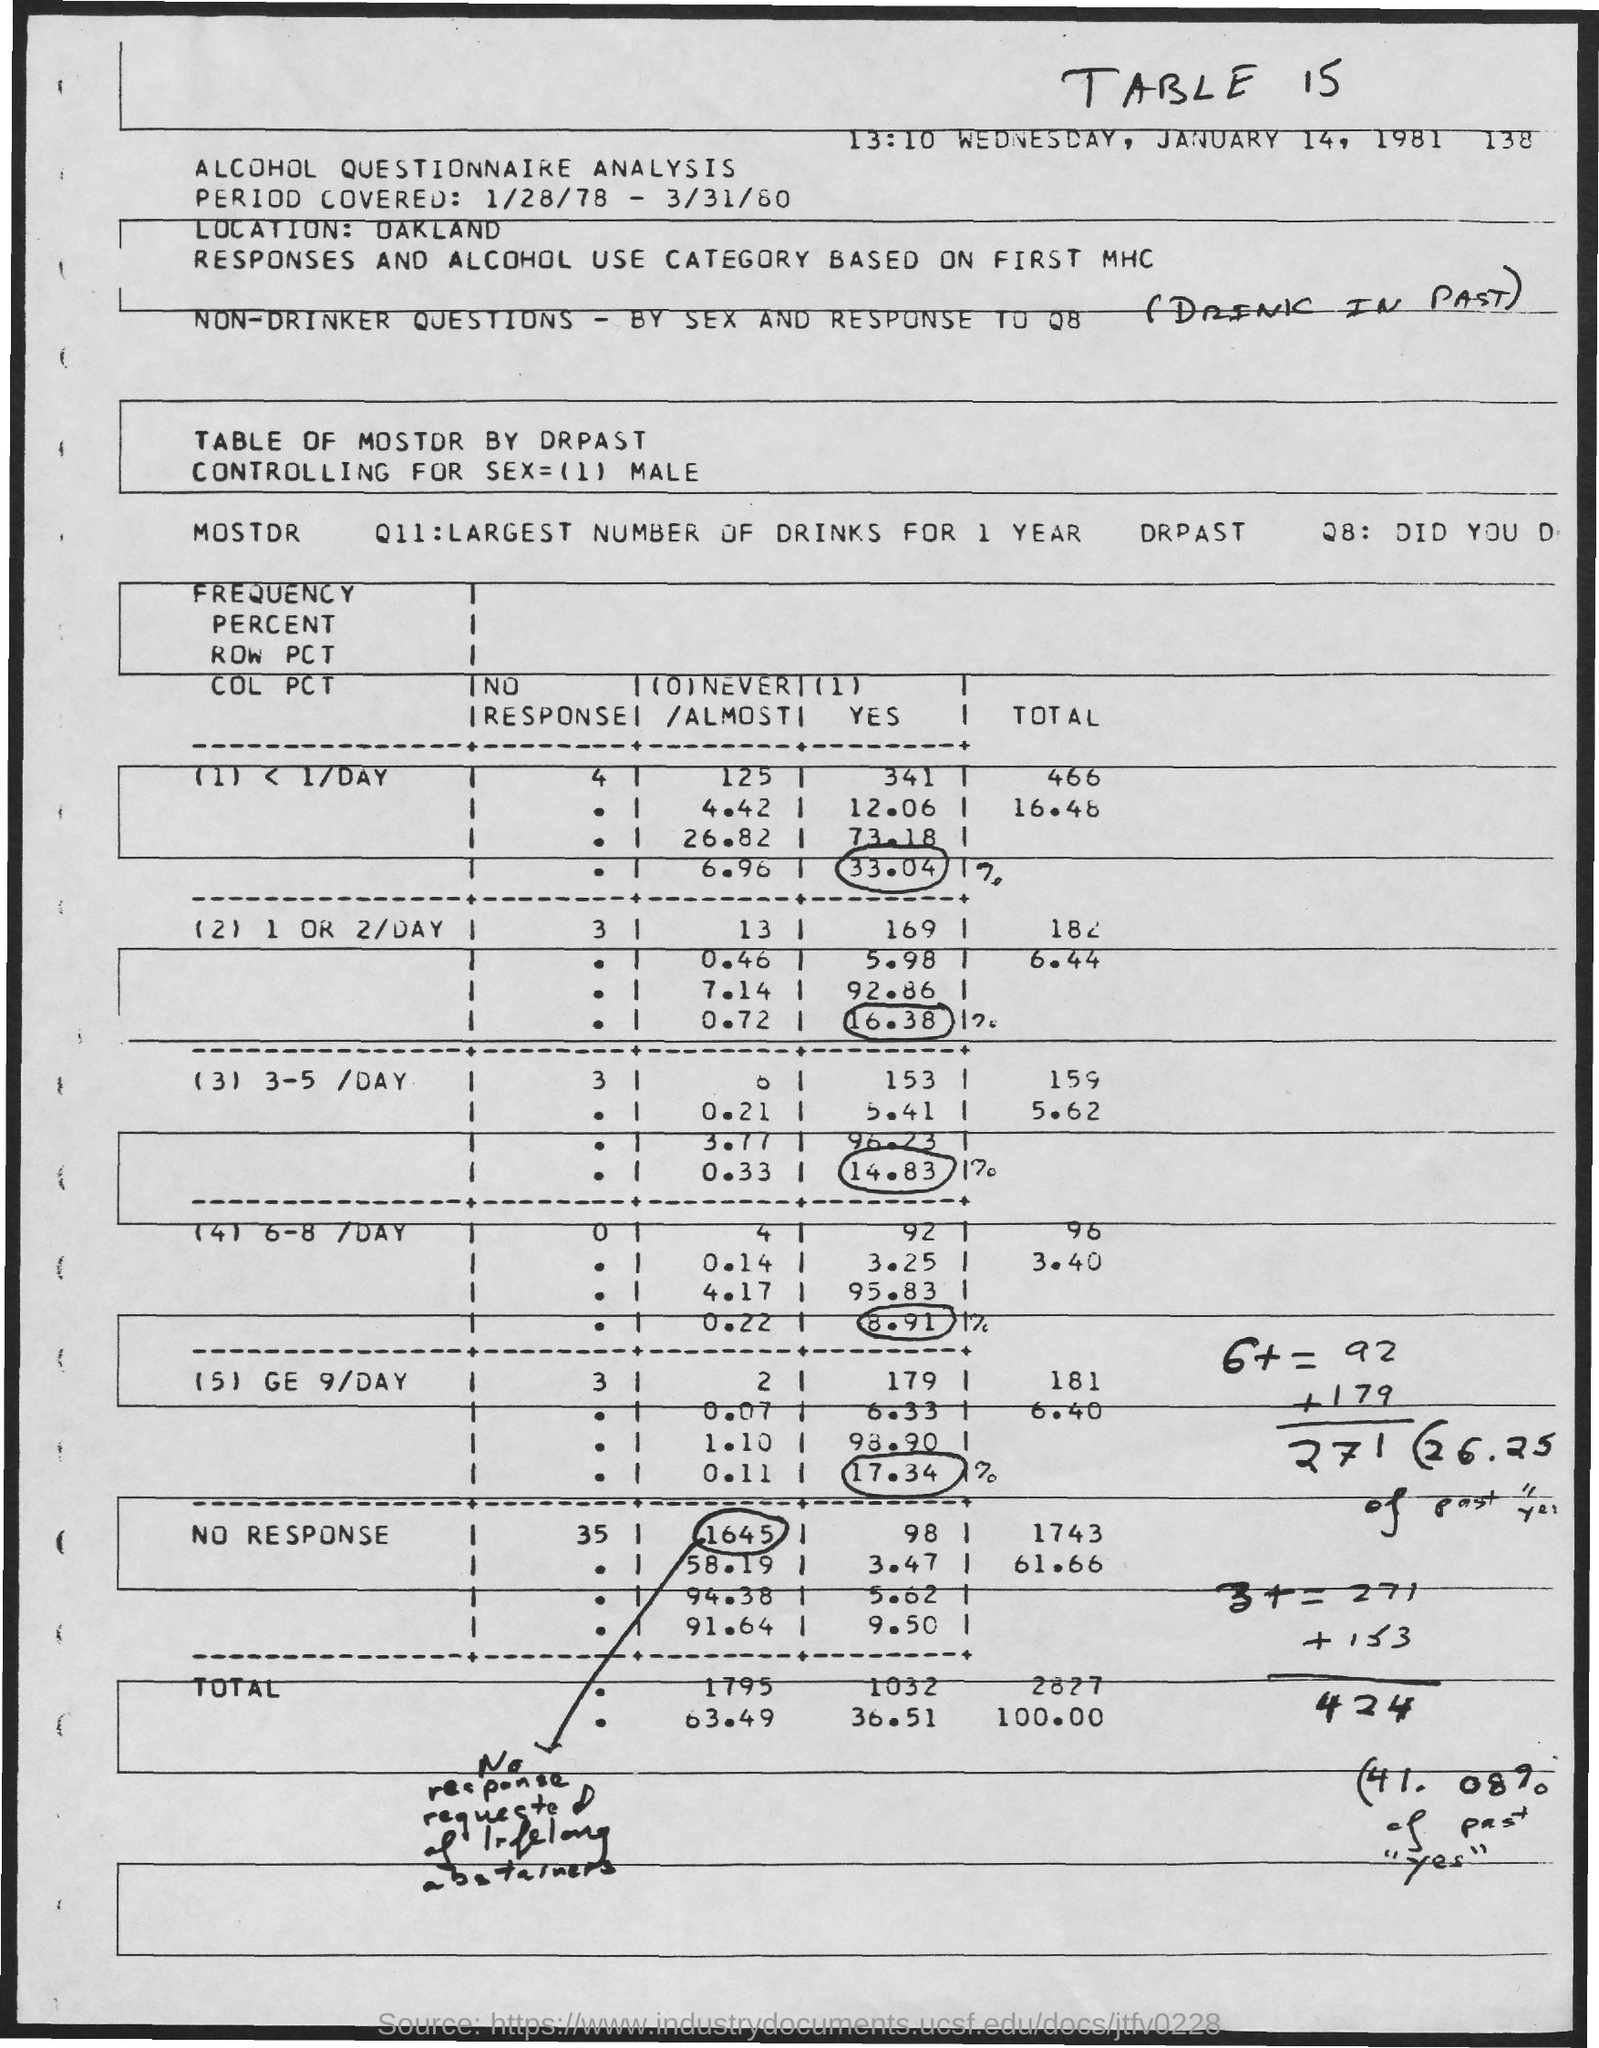What is the table number?
Your answer should be very brief. Table 15. What is the location?
Offer a terse response. Oakland. 